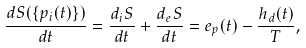Convert formula to latex. <formula><loc_0><loc_0><loc_500><loc_500>\frac { d S ( \{ p _ { i } ( t ) \} ) } { d t } = \frac { d _ { i } S } { d t } + \frac { d _ { e } S } { d t } = e _ { p } ( t ) - \frac { h _ { d } ( t ) } { T } ,</formula> 